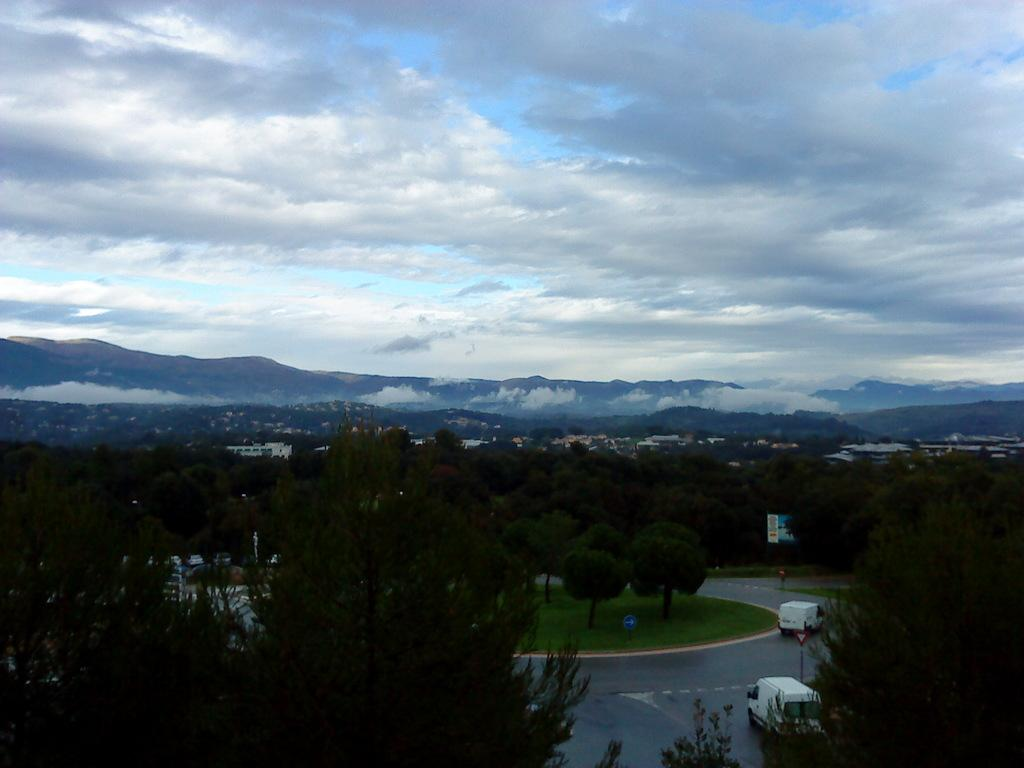What can be seen on the road in the image? There are vehicles on the road in the image. What structures are present in the image? There are poles, trees, buildings, and hills in the image. What is visible in the background of the image? The sky is visible in the background of the image. Can you tell me where the pot is located in the image? There is no pot present in the image. Are there any servants visible in the image? There are no servants present in the image. 